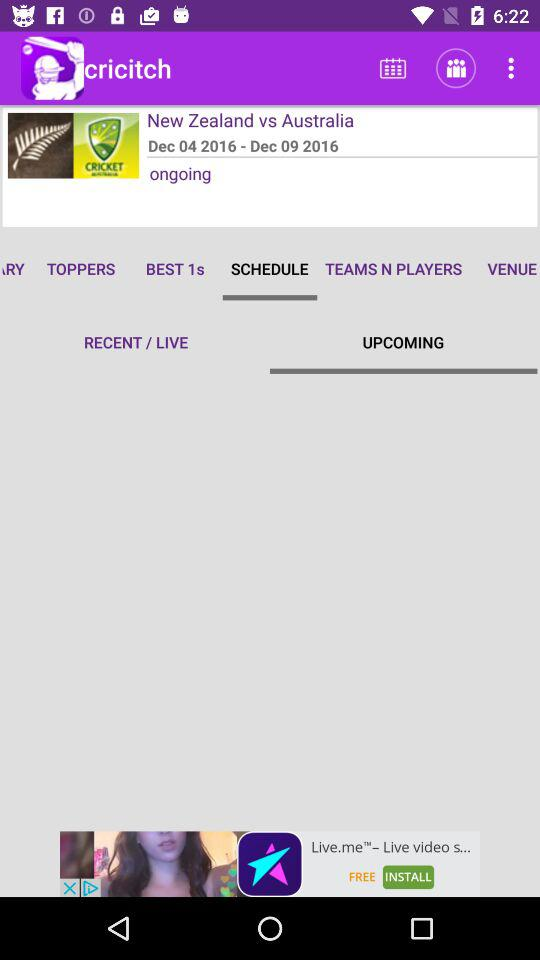What is the date range for the ongoing match between New Zealand and Australia? The date range is from December 04, 2016 to December 09, 2016. 